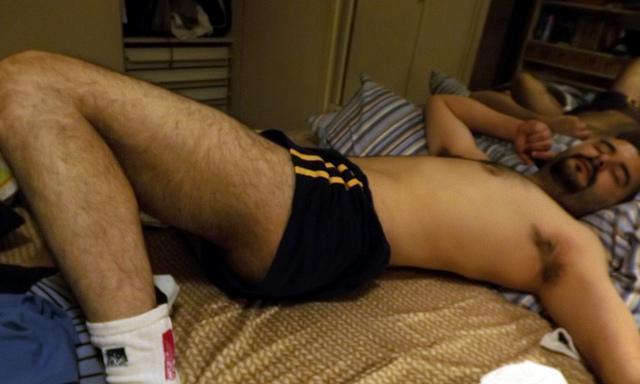How many people are in the photo?
Give a very brief answer. 2. How many people have a umbrella in the picture?
Give a very brief answer. 0. 